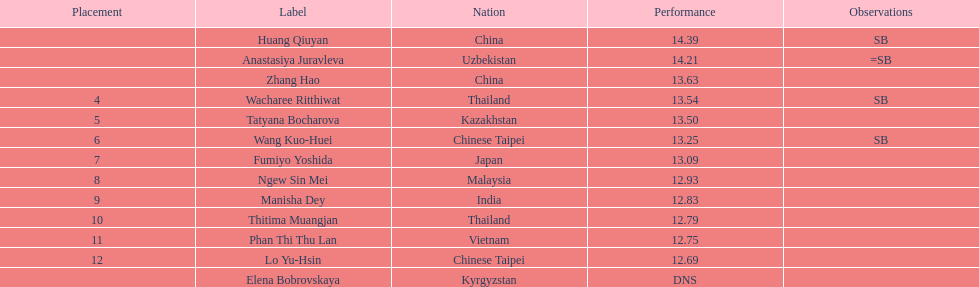The woman who took first place belonged to which nationality? China. 